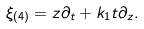Convert formula to latex. <formula><loc_0><loc_0><loc_500><loc_500>\xi _ { ( 4 ) } = z \partial _ { t } + k _ { 1 } t \partial _ { z } .</formula> 